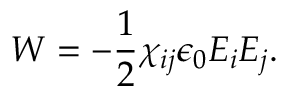Convert formula to latex. <formula><loc_0><loc_0><loc_500><loc_500>W = - \frac { 1 } { 2 } \chi _ { i j } \epsilon _ { 0 } E _ { i } E _ { j } .</formula> 